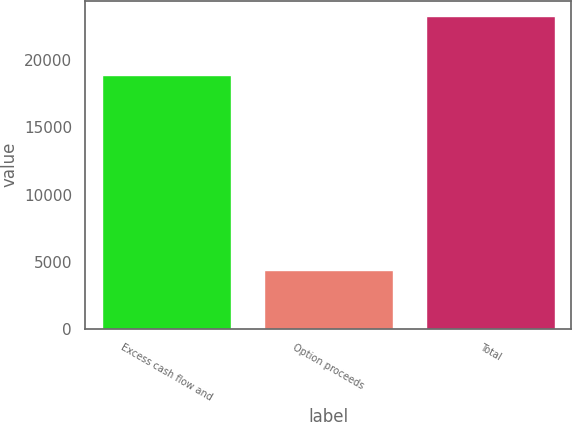Convert chart. <chart><loc_0><loc_0><loc_500><loc_500><bar_chart><fcel>Excess cash flow and<fcel>Option proceeds<fcel>Total<nl><fcel>18901<fcel>4380<fcel>23281<nl></chart> 